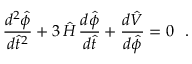Convert formula to latex. <formula><loc_0><loc_0><loc_500><loc_500>\frac { d ^ { 2 } { \hat { \phi } } } { d { \hat { t } } ^ { 2 } } + 3 \, { \hat { H } } \, \frac { d { \hat { \phi } } } { d { \hat { t } } } + \frac { d { \hat { V } } } { d { \hat { \phi } } } = 0 .</formula> 